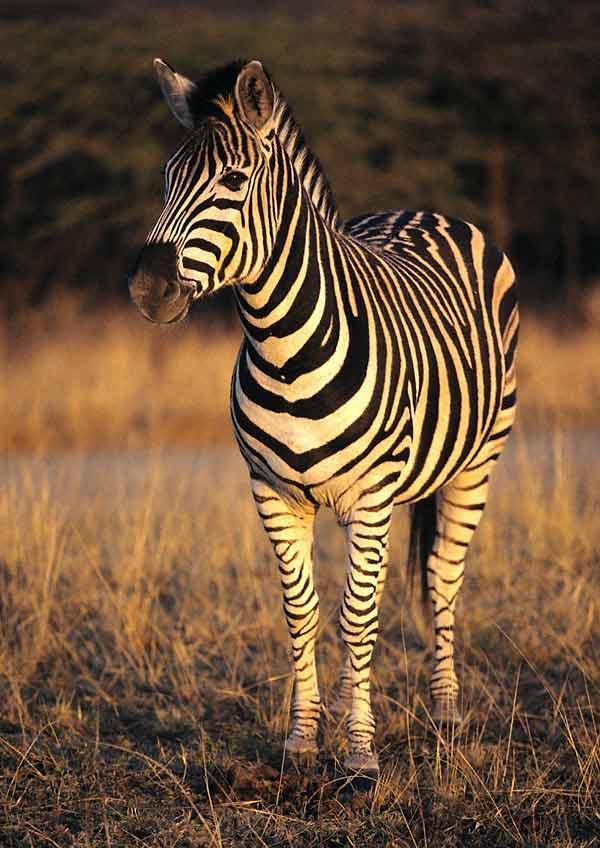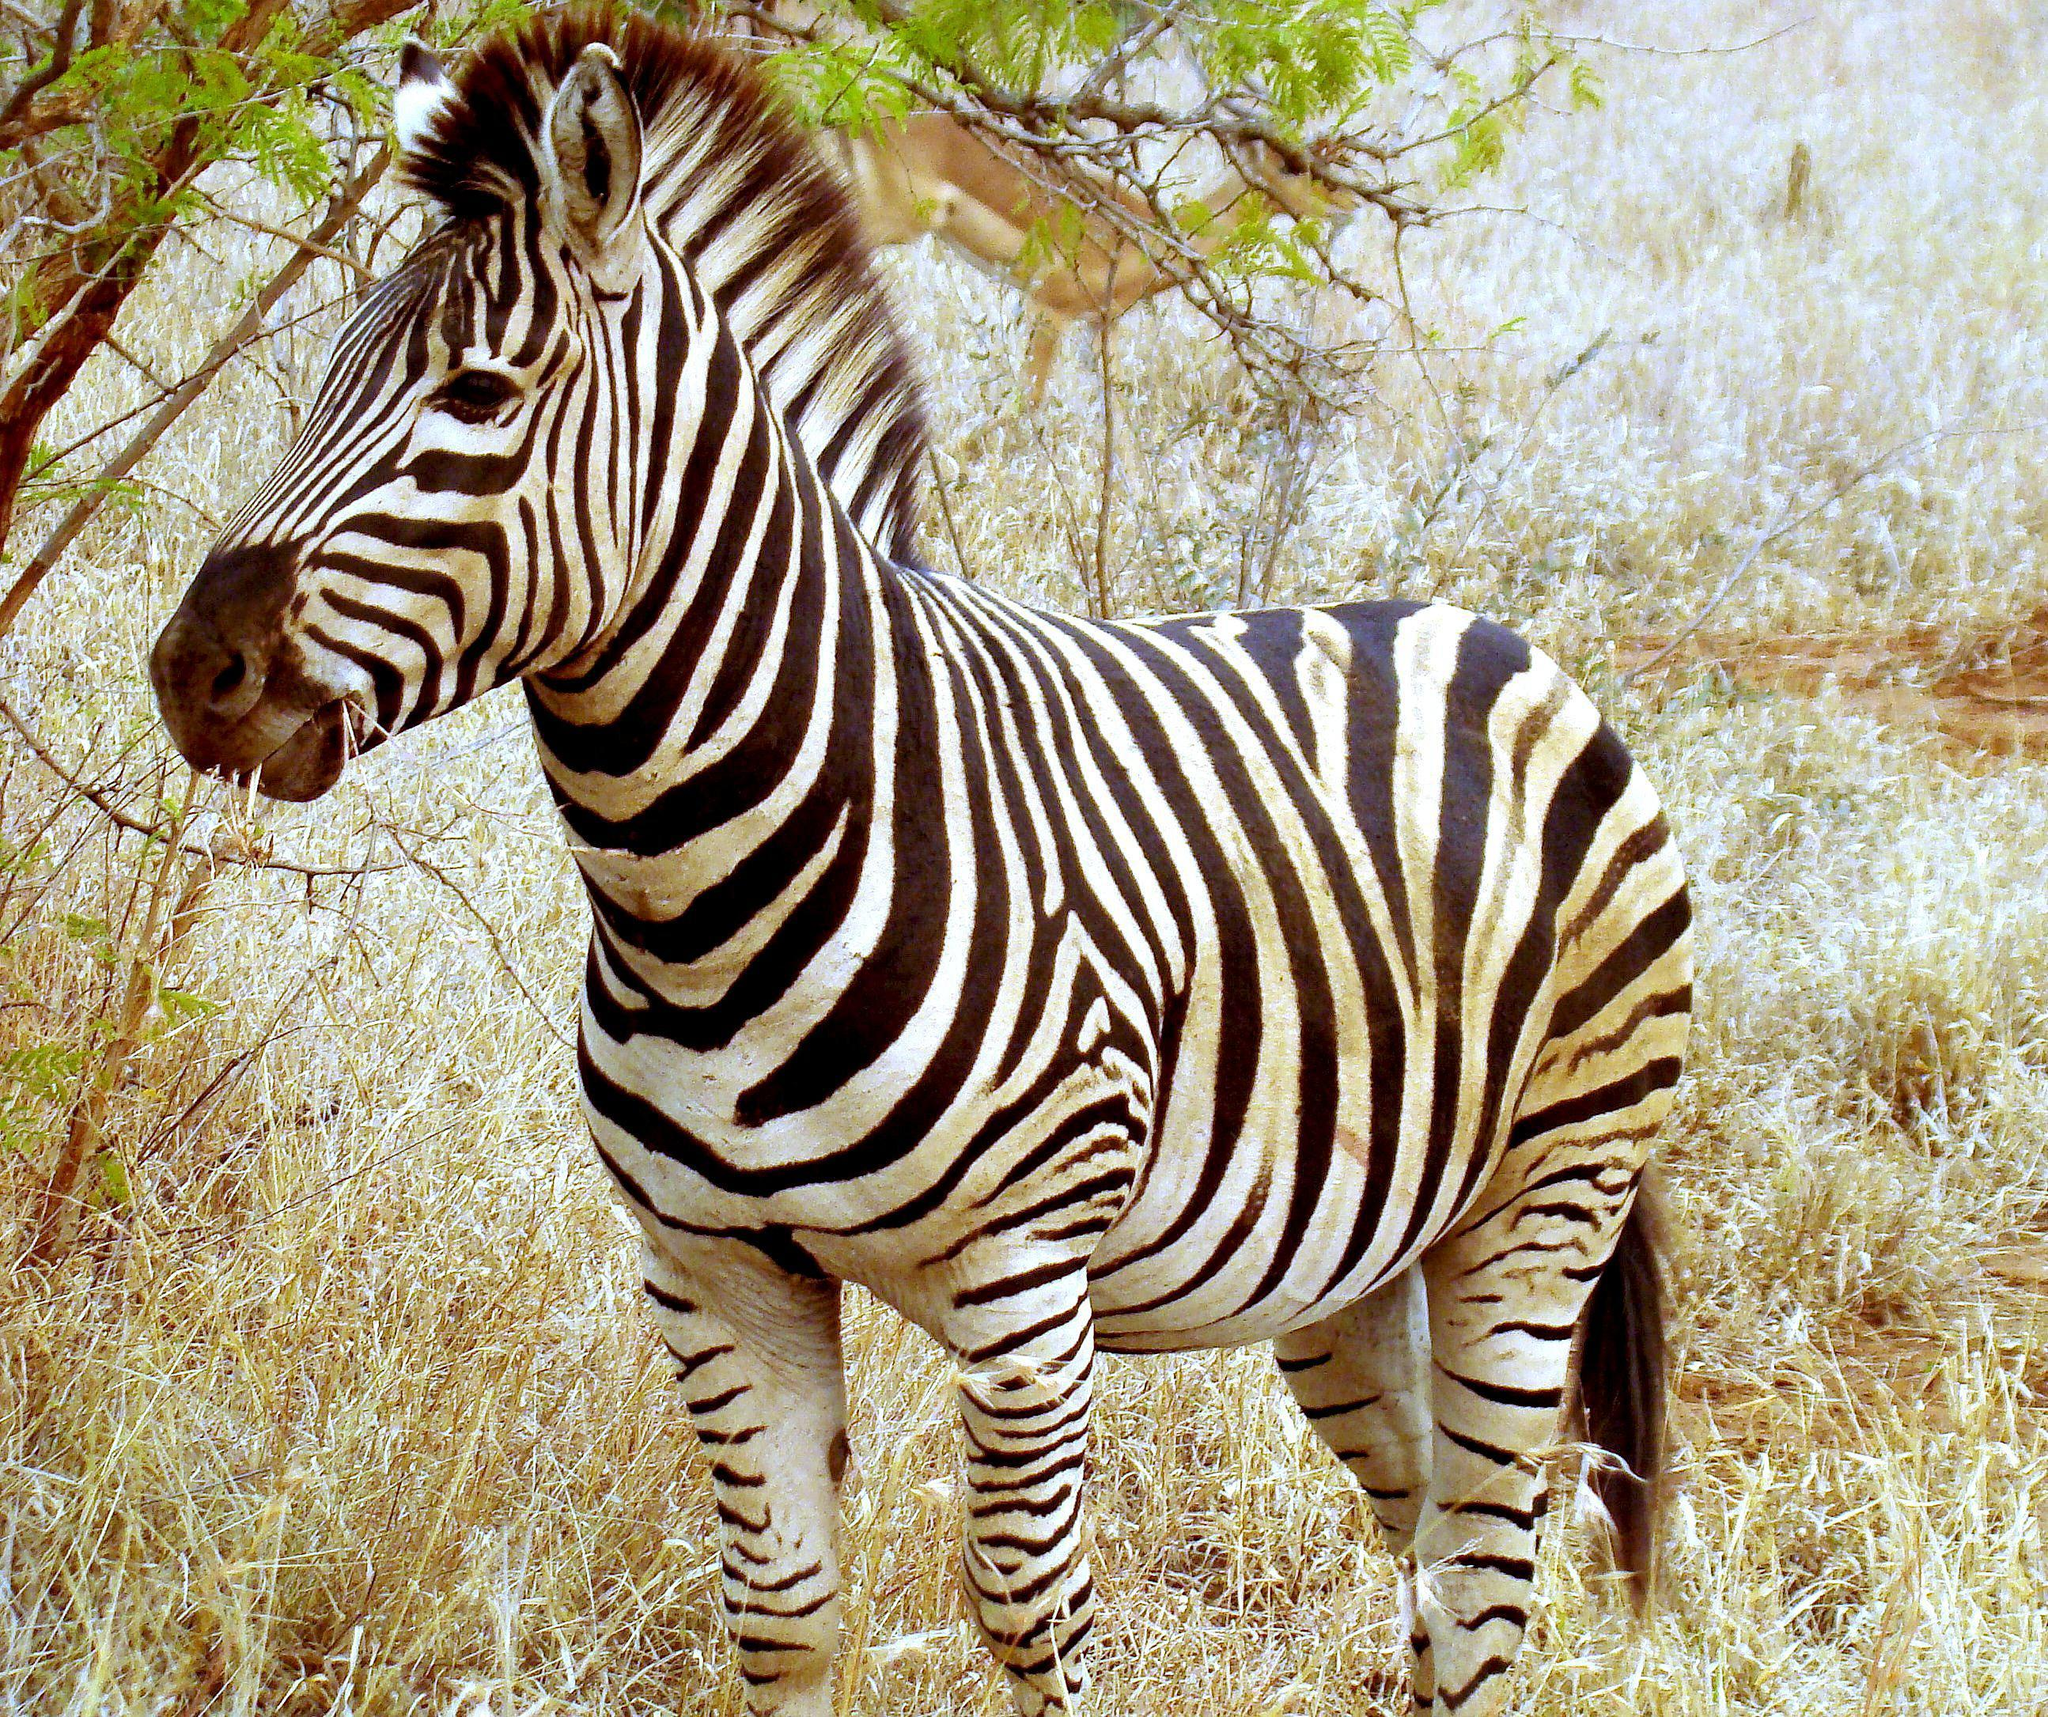The first image is the image on the left, the second image is the image on the right. Considering the images on both sides, is "There are exactly two zebras in the left image." valid? Answer yes or no. No. The first image is the image on the left, the second image is the image on the right. For the images shown, is this caption "There are at most 6 zebras in the image pair" true? Answer yes or no. Yes. 